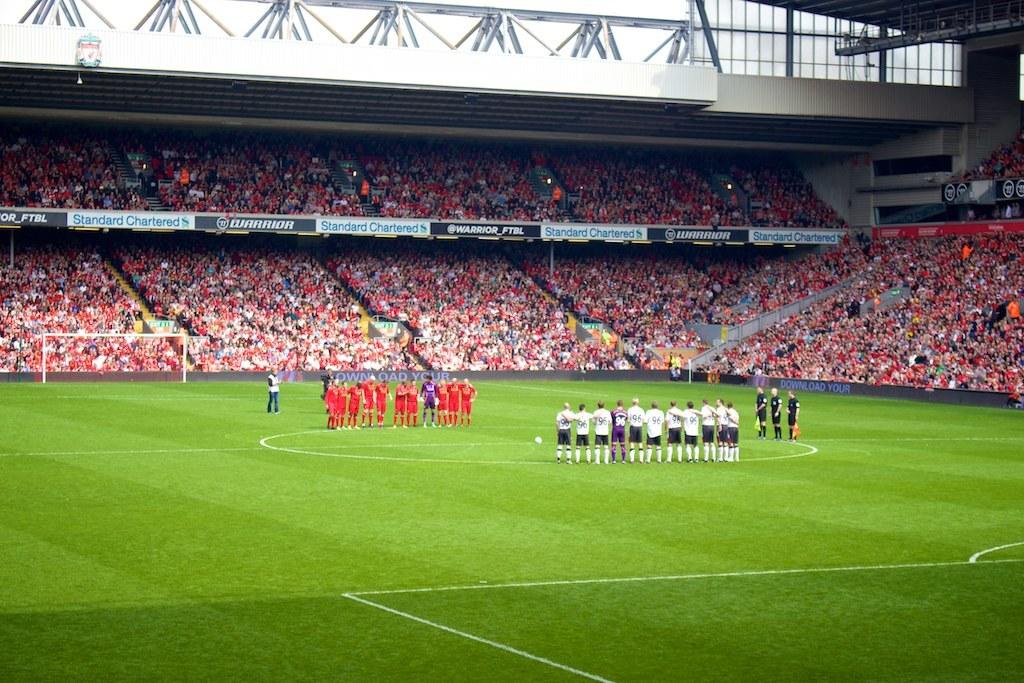What is a number of anyone in the white jersey's?
Your answer should be compact. 96. Is this stadium empty?
Provide a succinct answer. Answering does not require reading text in the image. 